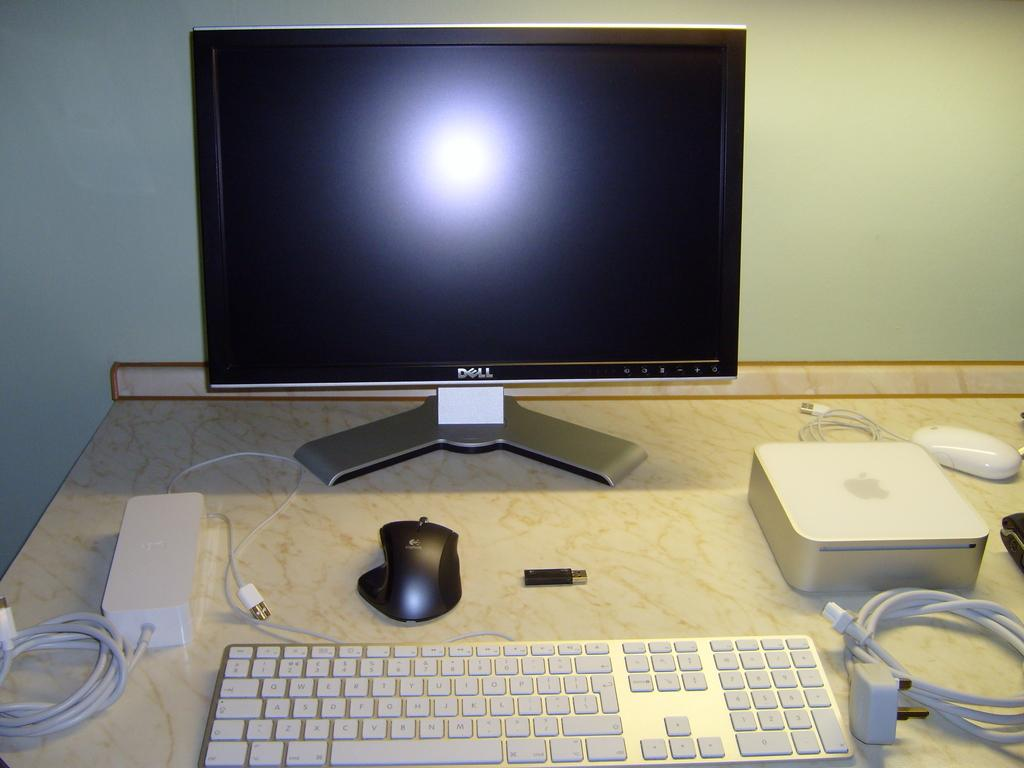<image>
Share a concise interpretation of the image provided. the word Dell that is on a computer monitor 